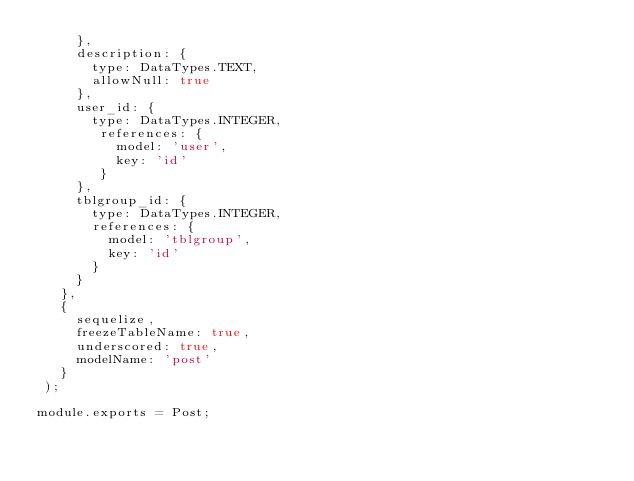<code> <loc_0><loc_0><loc_500><loc_500><_JavaScript_>     },
     description: {
       type: DataTypes.TEXT,
       allowNull: true
     },
     user_id: {
       type: DataTypes.INTEGER,
        references: {
          model: 'user',
          key: 'id'
        }
     },
     tblgroup_id: {
       type: DataTypes.INTEGER,
       references: {
         model: 'tblgroup',
         key: 'id'
       }
     }
   },
   {
     sequelize,
     freezeTableName: true,
     underscored: true,
     modelName: 'post'
   }
 );

module.exports = Post;
</code> 